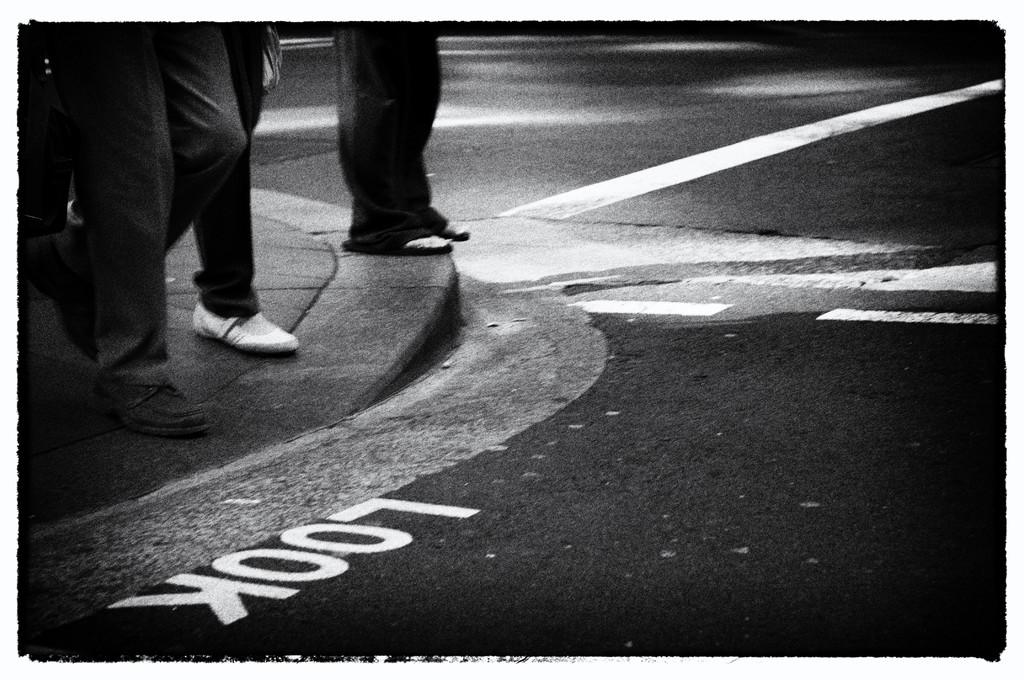What is the color scheme of the image? The picture is black and white. What can be seen on the floor in the image? There are legs of some persons visible on the floor in the image. What hobbies do the persons in the image have? There is no information about the hobbies of the persons in the image, as it only shows their legs on the floor. What is the curve of the floor in the image? There is no curve of the floor mentioned in the image, as it only shows legs of some persons on a flat surface. 